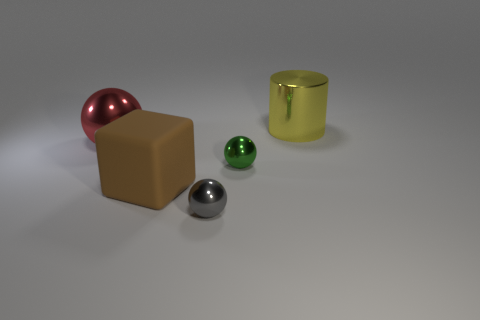Is there a gray shiny ball that has the same size as the red ball?
Provide a short and direct response. No. How many other gray balls are the same size as the gray ball?
Your answer should be very brief. 0. Do the shiny sphere to the left of the block and the object behind the red sphere have the same size?
Your answer should be very brief. Yes. How many things are tiny brown metallic cylinders or small spheres in front of the tiny green metallic ball?
Give a very brief answer. 1. What color is the cube?
Offer a very short reply. Brown. There is a ball that is to the left of the large object in front of the big shiny thing in front of the yellow thing; what is its material?
Make the answer very short. Metal. What size is the gray ball that is the same material as the green object?
Ensure brevity in your answer.  Small. Is there a metallic sphere of the same color as the big metallic cylinder?
Offer a very short reply. No. There is a gray thing; is its size the same as the object that is behind the red metallic ball?
Make the answer very short. No. There is a big shiny thing on the right side of the metal thing left of the brown matte cube; what number of yellow objects are right of it?
Make the answer very short. 0. 